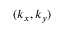Convert formula to latex. <formula><loc_0><loc_0><loc_500><loc_500>( k _ { x } , k _ { y } )</formula> 